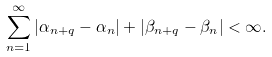<formula> <loc_0><loc_0><loc_500><loc_500>\sum _ { n = 1 } ^ { \infty } | \alpha _ { n + q } - \alpha _ { n } | + | \beta _ { n + q } - \beta _ { n } | < \infty .</formula> 